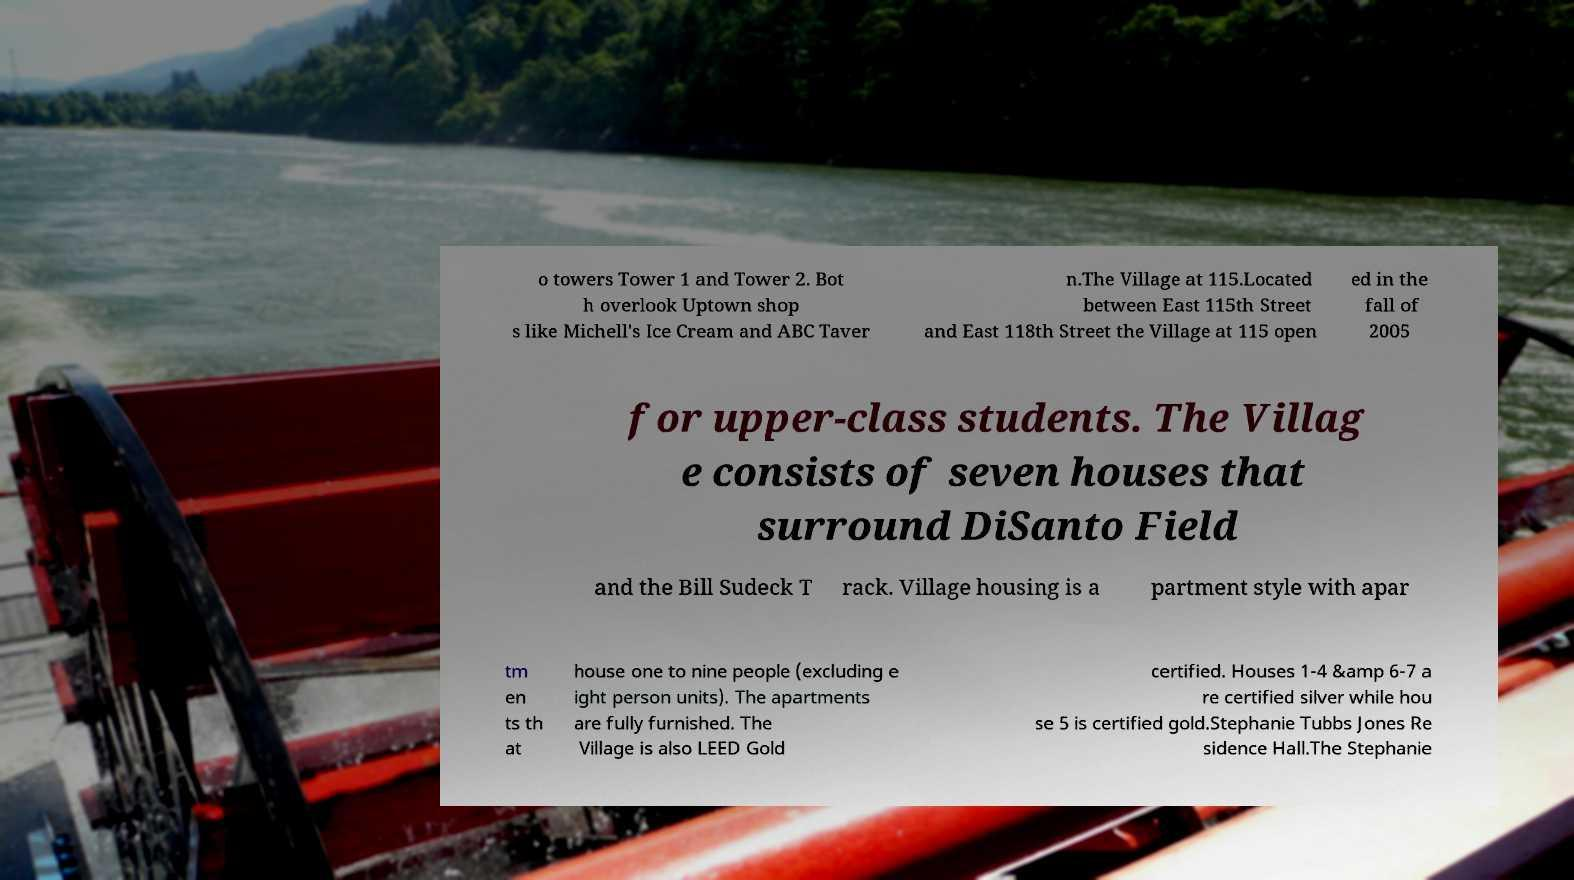Can you read and provide the text displayed in the image?This photo seems to have some interesting text. Can you extract and type it out for me? o towers Tower 1 and Tower 2. Bot h overlook Uptown shop s like Michell's Ice Cream and ABC Taver n.The Village at 115.Located between East 115th Street and East 118th Street the Village at 115 open ed in the fall of 2005 for upper-class students. The Villag e consists of seven houses that surround DiSanto Field and the Bill Sudeck T rack. Village housing is a partment style with apar tm en ts th at house one to nine people (excluding e ight person units). The apartments are fully furnished. The Village is also LEED Gold certified. Houses 1-4 &amp 6-7 a re certified silver while hou se 5 is certified gold.Stephanie Tubbs Jones Re sidence Hall.The Stephanie 